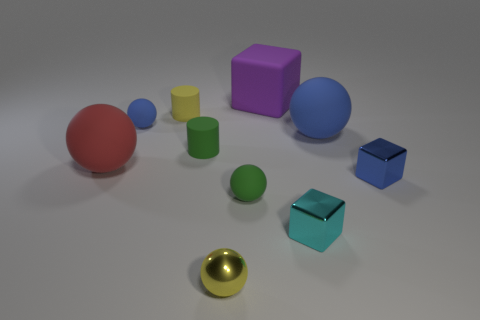There is a small rubber object in front of the ball that is on the left side of the small blue object to the left of the large blue sphere; what color is it?
Offer a terse response. Green. Are there any other rubber objects of the same shape as the yellow rubber object?
Your answer should be compact. Yes. How many small blue rubber things are there?
Your response must be concise. 1. There is a big blue rubber thing; what shape is it?
Your answer should be compact. Sphere. What number of red spheres have the same size as the purple rubber thing?
Make the answer very short. 1. Is the big purple rubber thing the same shape as the large blue rubber object?
Give a very brief answer. No. What is the color of the large rubber sphere that is behind the tiny green rubber object behind the small blue metallic thing?
Your answer should be compact. Blue. There is a sphere that is behind the large red thing and on the left side of the tiny cyan shiny thing; what size is it?
Keep it short and to the point. Small. Is there any other thing that has the same color as the metal sphere?
Your answer should be very brief. Yes. The big purple object that is made of the same material as the large blue sphere is what shape?
Your response must be concise. Cube. 